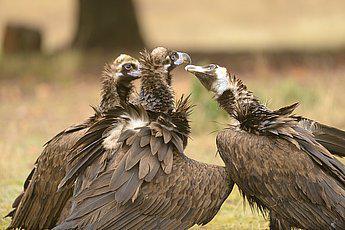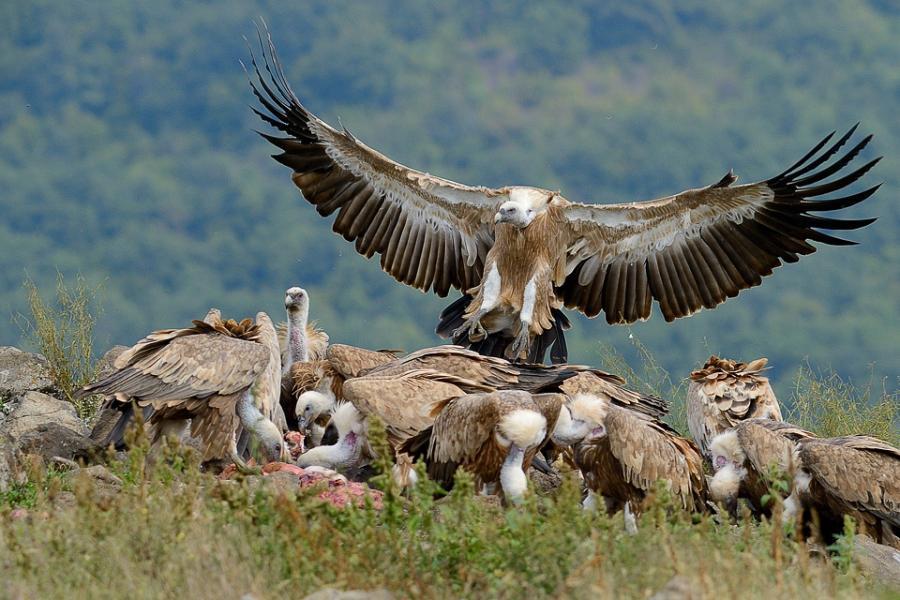The first image is the image on the left, the second image is the image on the right. Given the left and right images, does the statement "Right image shows a bird in the foreground with wings spread and off the ground." hold true? Answer yes or no. Yes. The first image is the image on the left, the second image is the image on the right. Examine the images to the left and right. Is the description "One image in the pair includes vultures with a carcass." accurate? Answer yes or no. Yes. 